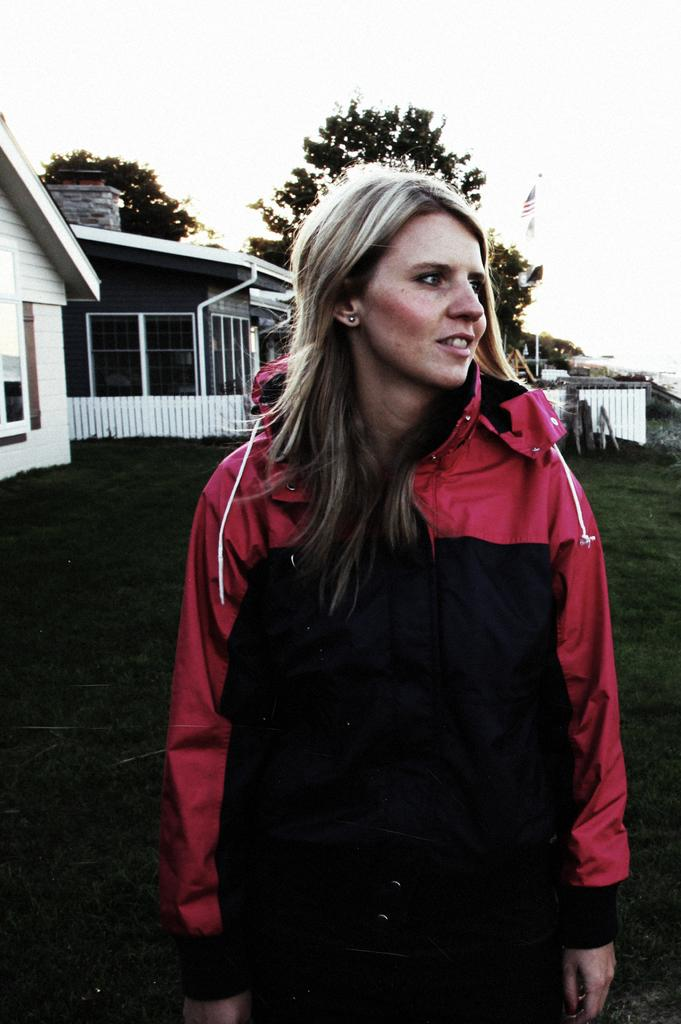Who is the main subject in the image? There is a woman in the image. What is the woman doing in the image? The woman is standing. What is the woman wearing in the image? The woman is wearing a black and red color coat. What can be seen in the background of the image? There are houses and trees in the background of the image. What is visible at the top of the image? The sky is visible at the top of the image. What type of hole can be seen in the image? There is no hole present in the image. What is the woman reading in the image? The image does not show the woman reading anything. 